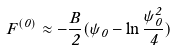<formula> <loc_0><loc_0><loc_500><loc_500>F ^ { ( 0 ) } \approx - \frac { B } { 2 } ( \psi _ { 0 } - \ln \frac { \psi _ { 0 } ^ { 2 } } { 4 } )</formula> 